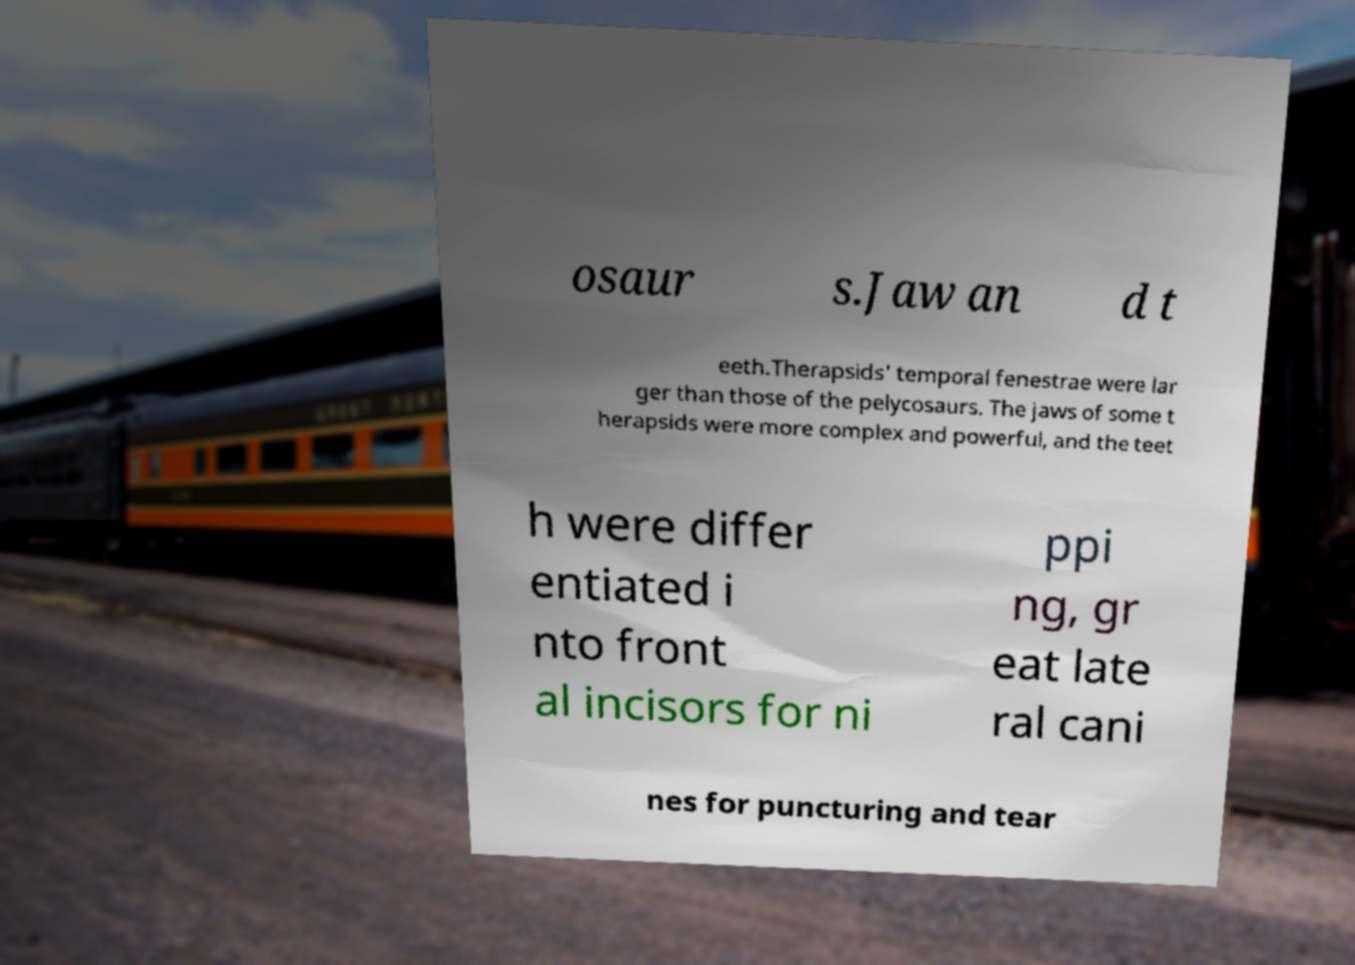Please read and relay the text visible in this image. What does it say? osaur s.Jaw an d t eeth.Therapsids' temporal fenestrae were lar ger than those of the pelycosaurs. The jaws of some t herapsids were more complex and powerful, and the teet h were differ entiated i nto front al incisors for ni ppi ng, gr eat late ral cani nes for puncturing and tear 